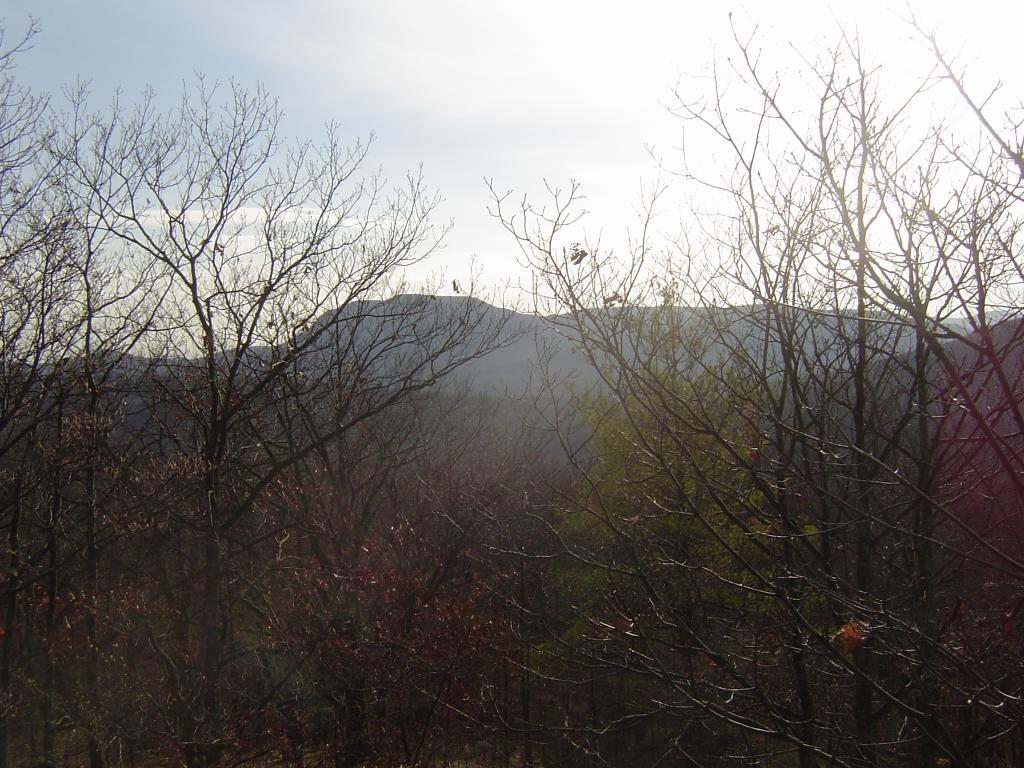What type of vegetation is in the foreground of the image? There are trees in the foreground of the image. What geographical feature can be seen in the background of the image? There is a mountain in the background of the image. What is visible at the top of the image? The sky is visible at the top of the image. What can be observed in the sky in the image? There are clouds in the sky. What type of lamp is hanging from the tree in the image? There is no lamp present in the image; it features trees, a mountain, and clouds in the sky. What religious symbol can be seen on the mountain in the image? There is no religious symbol present on the mountain in the image; it is a natural geographical feature. 